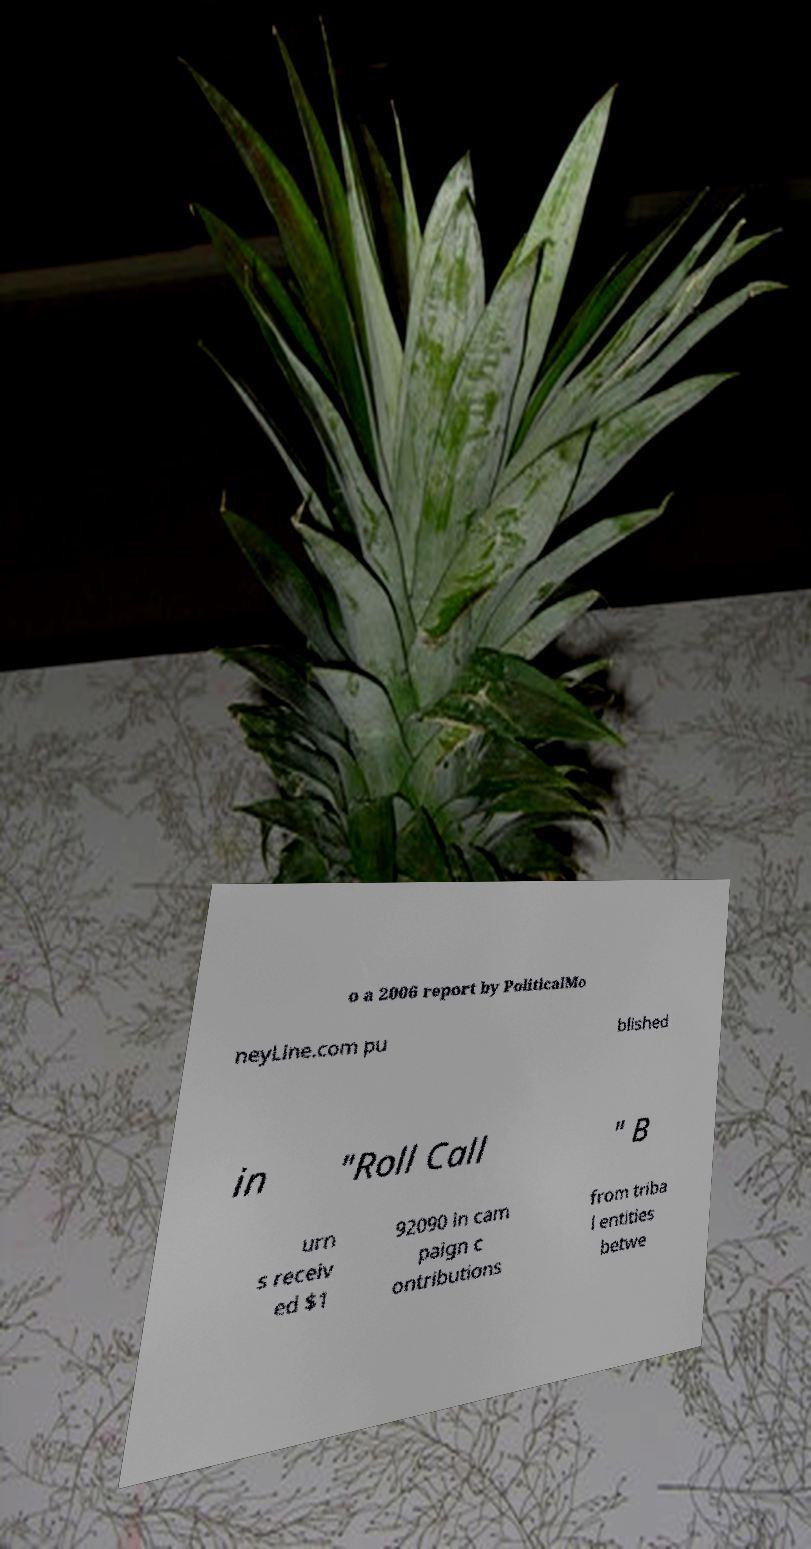I need the written content from this picture converted into text. Can you do that? o a 2006 report by PoliticalMo neyLine.com pu blished in "Roll Call " B urn s receiv ed $1 92090 in cam paign c ontributions from triba l entities betwe 